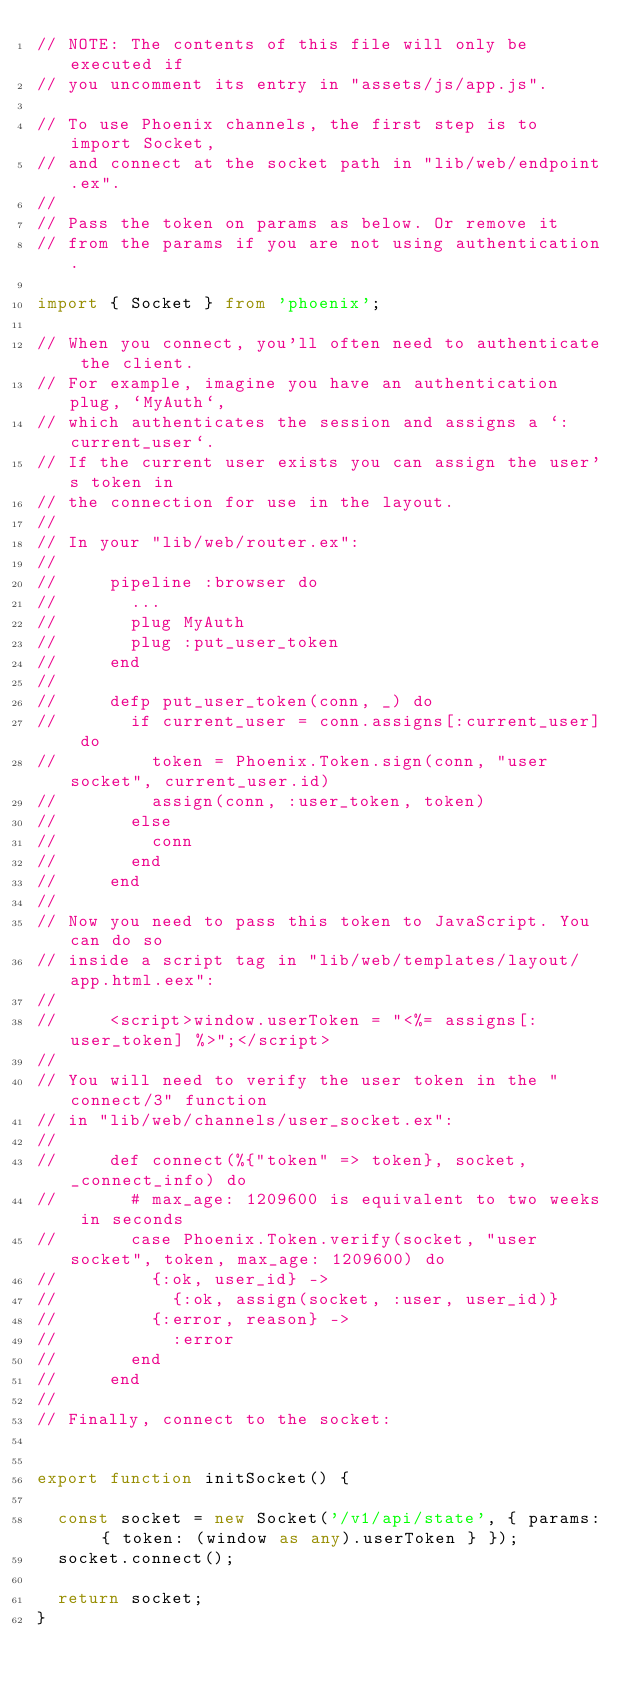<code> <loc_0><loc_0><loc_500><loc_500><_TypeScript_>// NOTE: The contents of this file will only be executed if
// you uncomment its entry in "assets/js/app.js".

// To use Phoenix channels, the first step is to import Socket,
// and connect at the socket path in "lib/web/endpoint.ex".
//
// Pass the token on params as below. Or remove it
// from the params if you are not using authentication.

import { Socket } from 'phoenix';

// When you connect, you'll often need to authenticate the client.
// For example, imagine you have an authentication plug, `MyAuth`,
// which authenticates the session and assigns a `:current_user`.
// If the current user exists you can assign the user's token in
// the connection for use in the layout.
//
// In your "lib/web/router.ex":
//
//     pipeline :browser do
//       ...
//       plug MyAuth
//       plug :put_user_token
//     end
//
//     defp put_user_token(conn, _) do
//       if current_user = conn.assigns[:current_user] do
//         token = Phoenix.Token.sign(conn, "user socket", current_user.id)
//         assign(conn, :user_token, token)
//       else
//         conn
//       end
//     end
//
// Now you need to pass this token to JavaScript. You can do so
// inside a script tag in "lib/web/templates/layout/app.html.eex":
//
//     <script>window.userToken = "<%= assigns[:user_token] %>";</script>
//
// You will need to verify the user token in the "connect/3" function
// in "lib/web/channels/user_socket.ex":
//
//     def connect(%{"token" => token}, socket, _connect_info) do
//       # max_age: 1209600 is equivalent to two weeks in seconds
//       case Phoenix.Token.verify(socket, "user socket", token, max_age: 1209600) do
//         {:ok, user_id} ->
//           {:ok, assign(socket, :user, user_id)}
//         {:error, reason} ->
//           :error
//       end
//     end
//
// Finally, connect to the socket:


export function initSocket() {

  const socket = new Socket('/v1/api/state', { params: { token: (window as any).userToken } });
  socket.connect();

  return socket;
}
</code> 